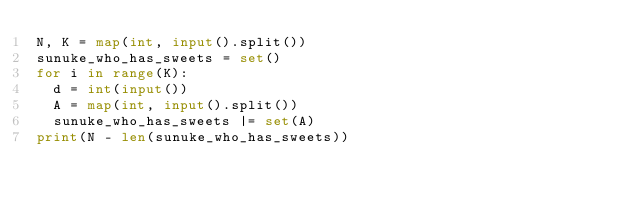<code> <loc_0><loc_0><loc_500><loc_500><_Python_>N, K = map(int, input().split())
sunuke_who_has_sweets = set()
for i in range(K):
  d = int(input())
  A = map(int, input().split())
  sunuke_who_has_sweets |= set(A)
print(N - len(sunuke_who_has_sweets))</code> 